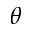Convert formula to latex. <formula><loc_0><loc_0><loc_500><loc_500>\theta</formula> 